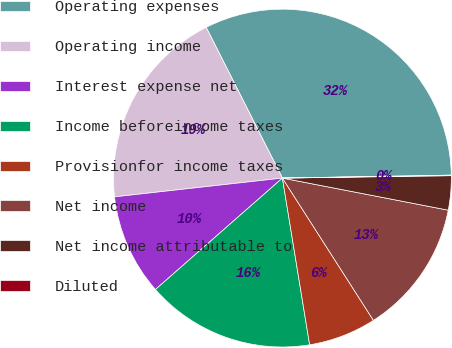<chart> <loc_0><loc_0><loc_500><loc_500><pie_chart><fcel>Operating expenses<fcel>Operating income<fcel>Interest expense net<fcel>Income beforeincome taxes<fcel>Provisionfor income taxes<fcel>Net income<fcel>Net income attributable to<fcel>Diluted<nl><fcel>32.17%<fcel>19.32%<fcel>9.69%<fcel>16.11%<fcel>6.48%<fcel>12.9%<fcel>3.27%<fcel>0.05%<nl></chart> 